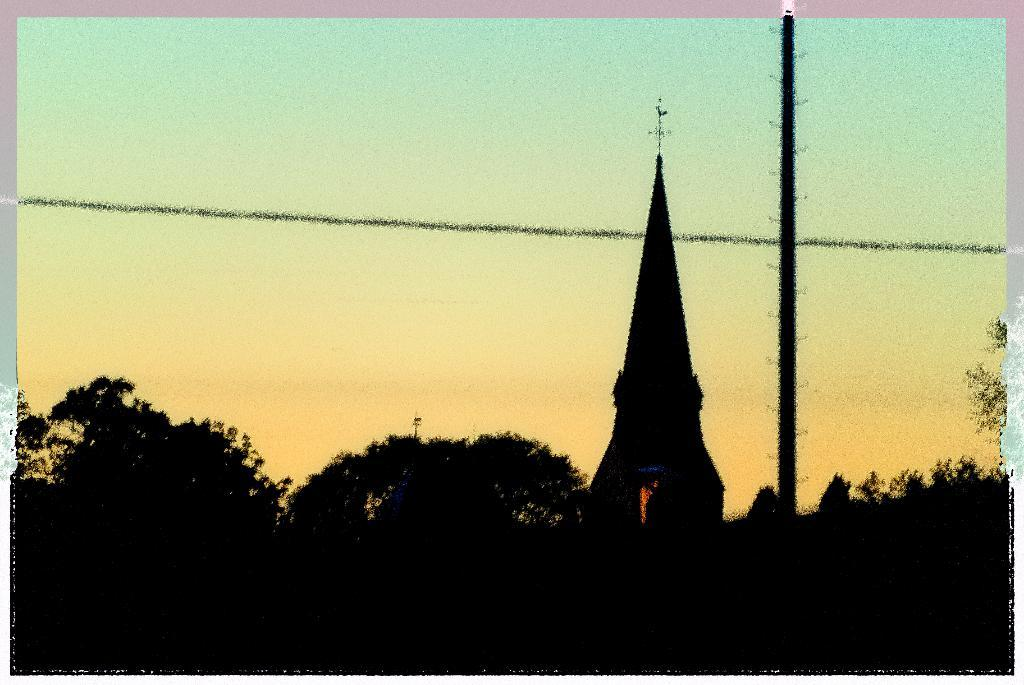What type of natural elements can be seen in the image? There are trees in the image. What type of building is present in the image? There is a church in the image. What other object can be seen in the image besides the trees and church? There is a pole in the image. What color is the lipstick on the door of the church in the image? There is no lipstick or door mentioned in the image; it only includes trees, a church, and a pole. 